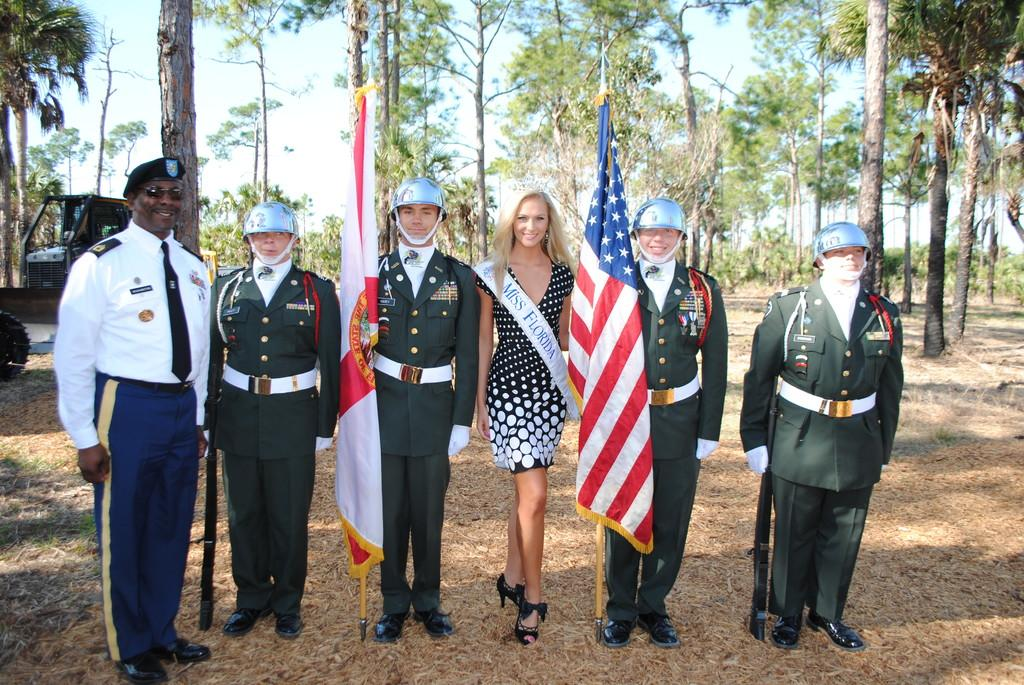How many people are in the image? There are six members in the image. Where are the members standing? The members are standing on the land. What are two of the members holding? Two of the members are holding flags. Where are the flags located in the image? The flags are in the middle of the picture. What can be seen in the background of the image? There is a sky visible in the background of the image. What type of connection can be seen between the members in the image? There is no specific connection between the members visible in the image. Can you tell me how many bees are flying around the flags in the image? There are no bees present in the image. 